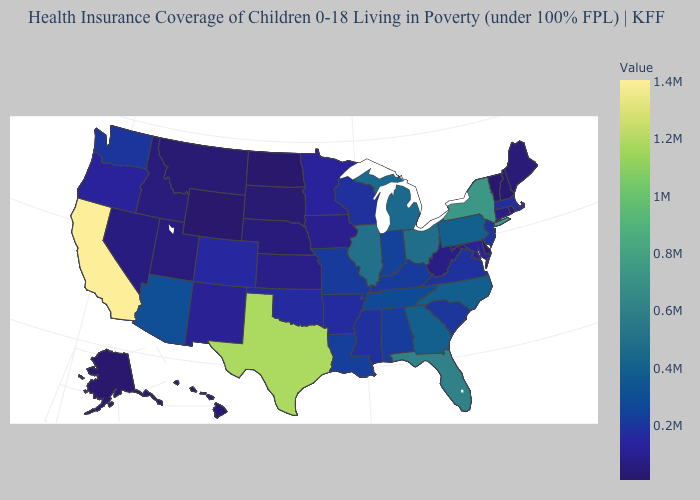Is the legend a continuous bar?
Answer briefly. Yes. Among the states that border Minnesota , which have the lowest value?
Be succinct. North Dakota. Does California have the highest value in the West?
Write a very short answer. Yes. 